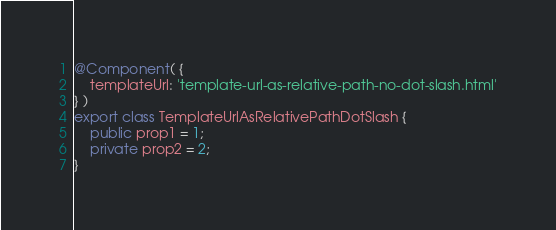Convert code to text. <code><loc_0><loc_0><loc_500><loc_500><_TypeScript_>@Component( {
	templateUrl: 'template-url-as-relative-path-no-dot-slash.html'
} )
export class TemplateUrlAsRelativePathDotSlash {
	public prop1 = 1;
	private prop2 = 2;
}</code> 